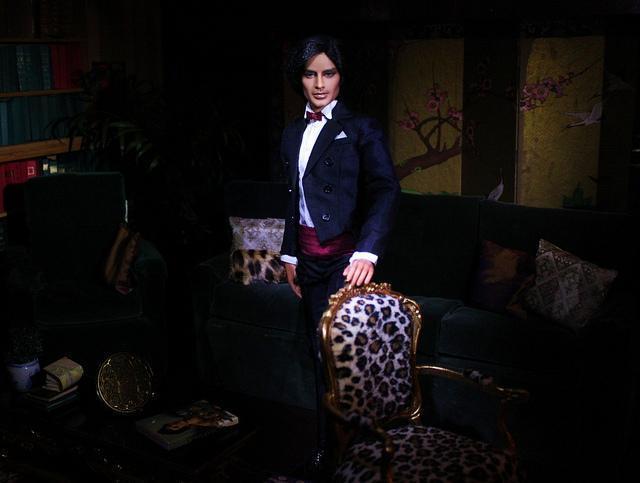How many people are in the photo?
Give a very brief answer. 1. How many chairs can you see?
Give a very brief answer. 4. How many motorcycles have two helmets?
Give a very brief answer. 0. 